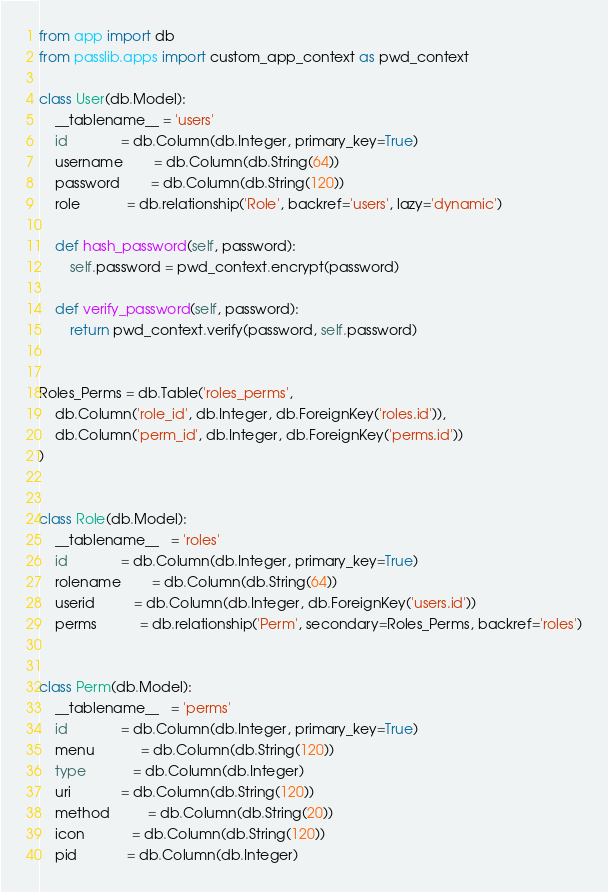<code> <loc_0><loc_0><loc_500><loc_500><_Python_>from app import db
from passlib.apps import custom_app_context as pwd_context

class User(db.Model):
    __tablename__ = 'users'
    id              = db.Column(db.Integer, primary_key=True)
    username        = db.Column(db.String(64))
    password        = db.Column(db.String(120))
    role            = db.relationship('Role', backref='users', lazy='dynamic')

    def hash_password(self, password):
        self.password = pwd_context.encrypt(password)

    def verify_password(self, password):
        return pwd_context.verify(password, self.password)


Roles_Perms = db.Table('roles_perms',
    db.Column('role_id', db.Integer, db.ForeignKey('roles.id')),
    db.Column('perm_id', db.Integer, db.ForeignKey('perms.id'))
)


class Role(db.Model):
    __tablename__   = 'roles'
    id              = db.Column(db.Integer, primary_key=True)
    rolename        = db.Column(db.String(64))
    userid          = db.Column(db.Integer, db.ForeignKey('users.id'))
    perms           = db.relationship('Perm', secondary=Roles_Perms, backref='roles')


class Perm(db.Model):
    __tablename__   = 'perms'
    id              = db.Column(db.Integer, primary_key=True)
    menu            = db.Column(db.String(120))
    type            = db.Column(db.Integer)
    uri             = db.Column(db.String(120))
    method          = db.Column(db.String(20))
    icon            = db.Column(db.String(120))
    pid             = db.Column(db.Integer)
</code> 